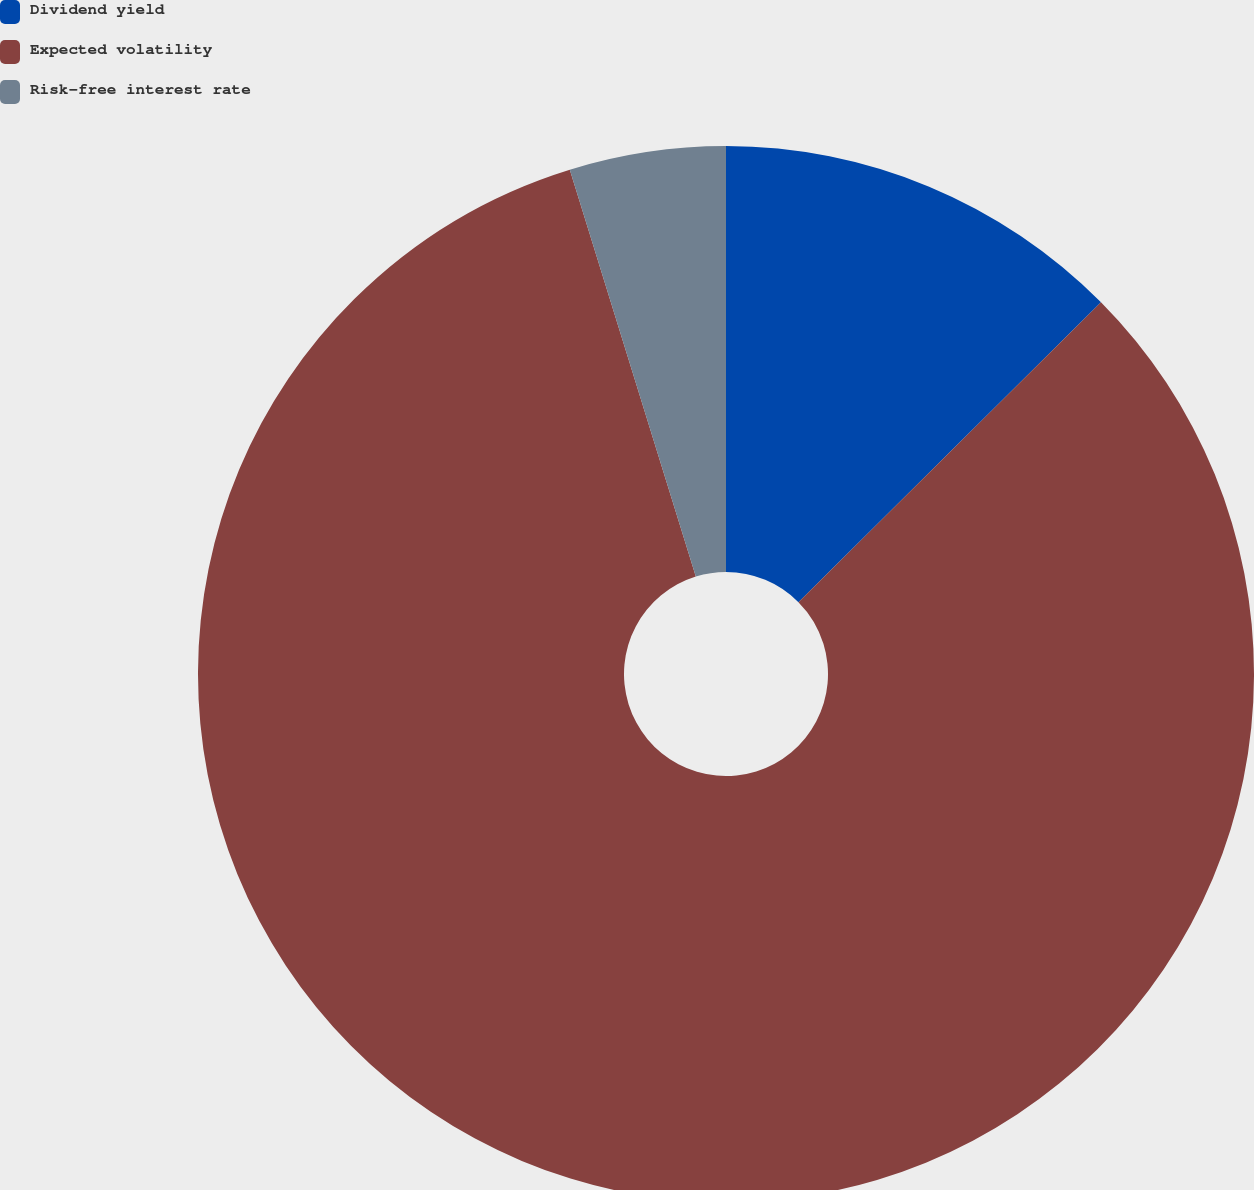<chart> <loc_0><loc_0><loc_500><loc_500><pie_chart><fcel>Dividend yield<fcel>Expected volatility<fcel>Risk-free interest rate<nl><fcel>12.57%<fcel>82.65%<fcel>4.78%<nl></chart> 